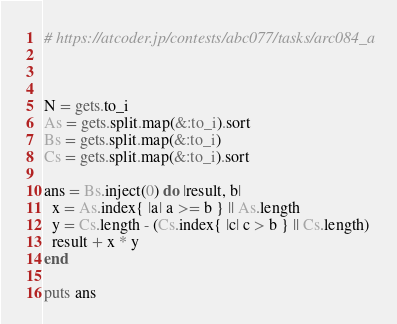<code> <loc_0><loc_0><loc_500><loc_500><_Ruby_># https://atcoder.jp/contests/abc077/tasks/arc084_a



N = gets.to_i
As = gets.split.map(&:to_i).sort
Bs = gets.split.map(&:to_i)
Cs = gets.split.map(&:to_i).sort

ans = Bs.inject(0) do |result, b|
  x = As.index{ |a| a >= b } || As.length
  y = Cs.length - (Cs.index{ |c| c > b } || Cs.length)
  result + x * y
end

puts ans
</code> 